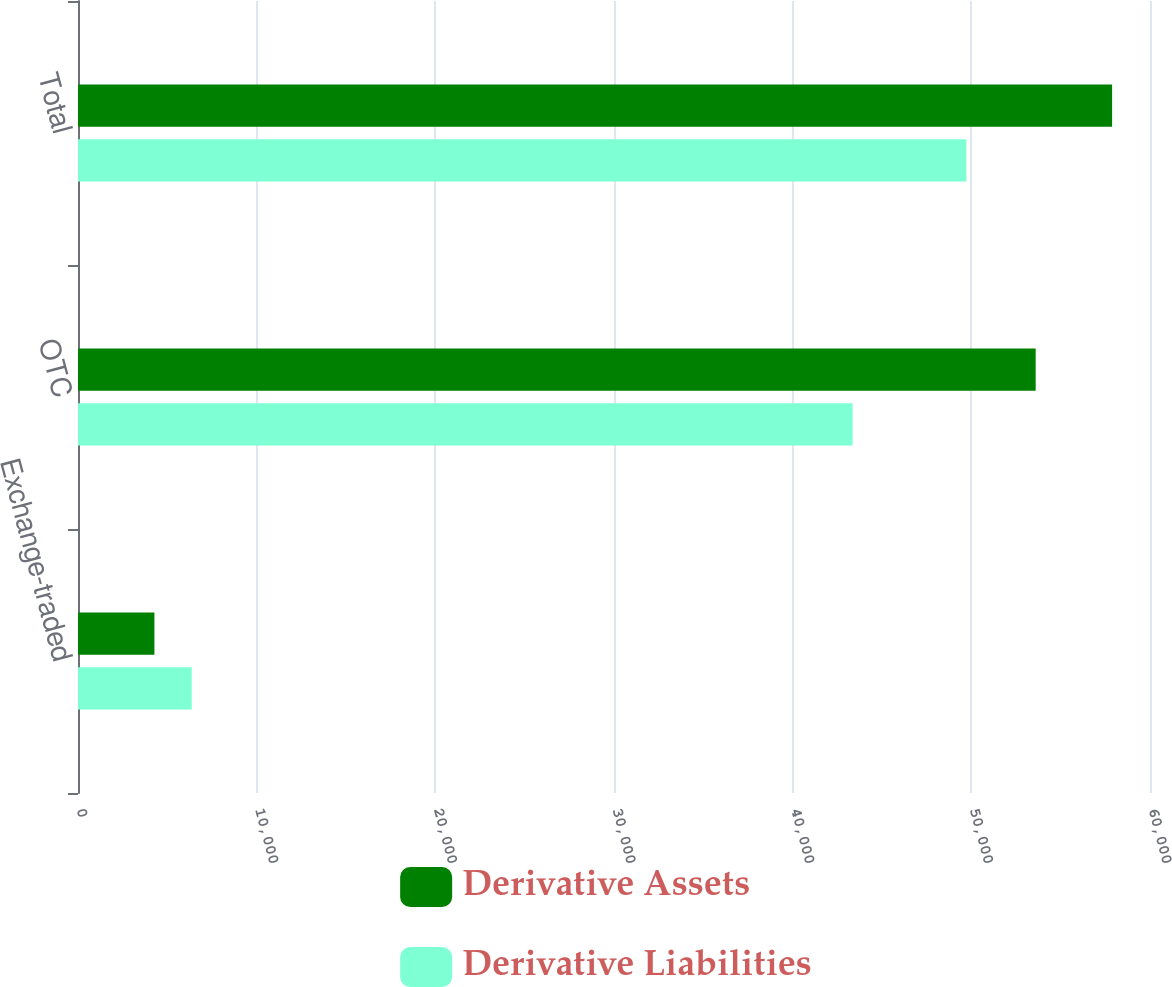<chart> <loc_0><loc_0><loc_500><loc_500><stacked_bar_chart><ecel><fcel>Exchange-traded<fcel>OTC<fcel>Total<nl><fcel>Derivative Assets<fcel>4277<fcel>53602<fcel>57879<nl><fcel>Derivative Liabilities<fcel>6366<fcel>43356<fcel>49722<nl></chart> 